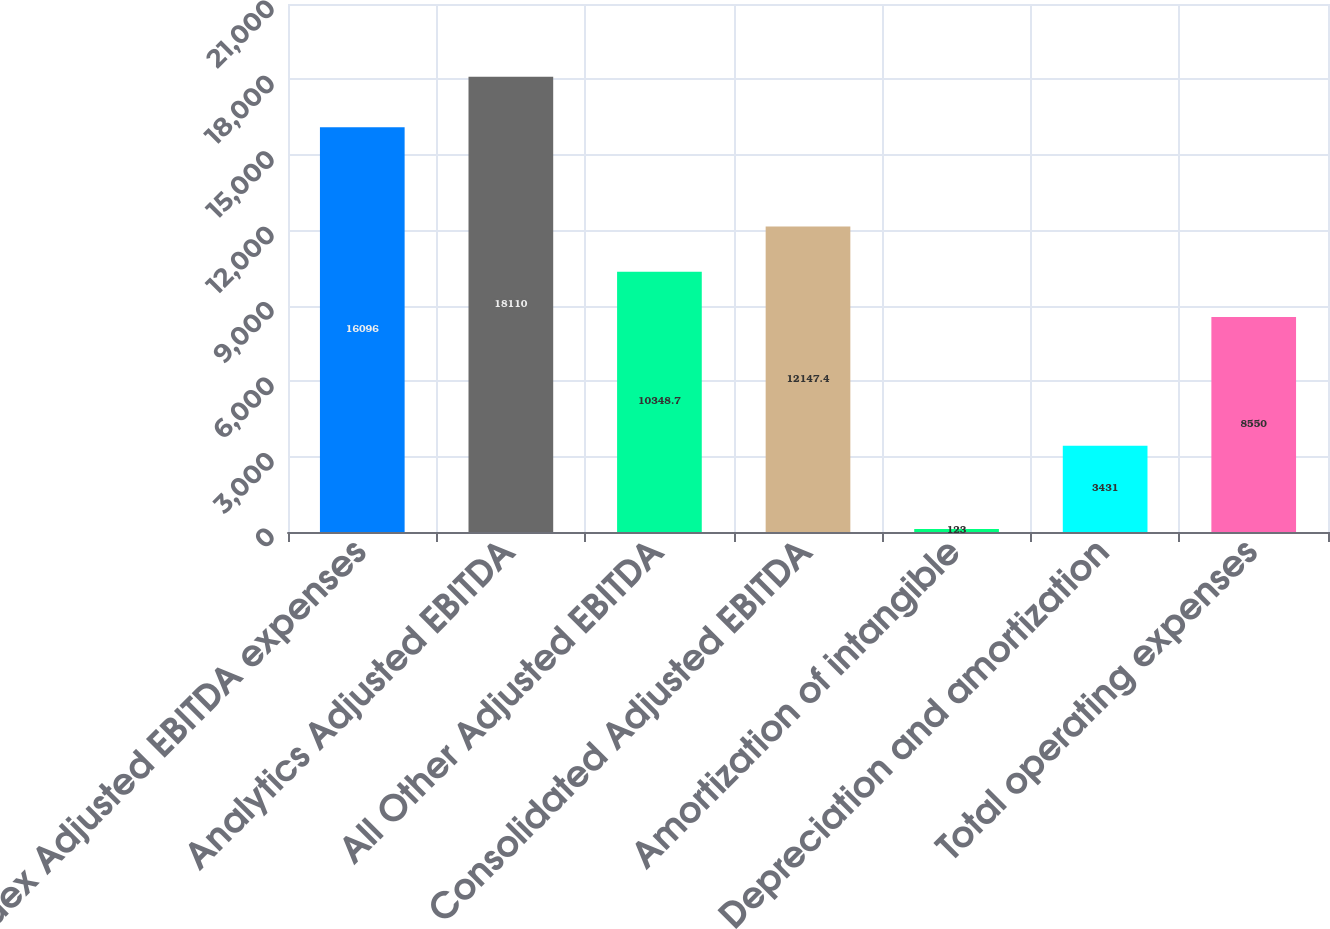Convert chart. <chart><loc_0><loc_0><loc_500><loc_500><bar_chart><fcel>Index Adjusted EBITDA expenses<fcel>Analytics Adjusted EBITDA<fcel>All Other Adjusted EBITDA<fcel>Consolidated Adjusted EBITDA<fcel>Amortization of intangible<fcel>Depreciation and amortization<fcel>Total operating expenses<nl><fcel>16096<fcel>18110<fcel>10348.7<fcel>12147.4<fcel>123<fcel>3431<fcel>8550<nl></chart> 